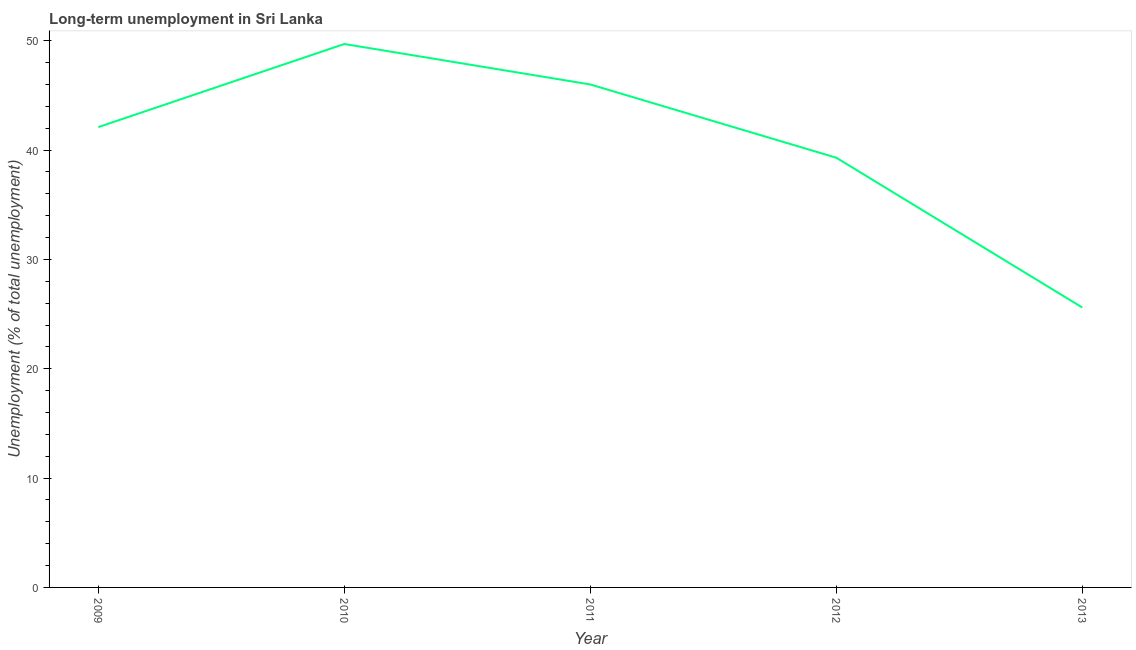What is the long-term unemployment in 2010?
Make the answer very short. 49.7. Across all years, what is the maximum long-term unemployment?
Make the answer very short. 49.7. Across all years, what is the minimum long-term unemployment?
Keep it short and to the point. 25.6. In which year was the long-term unemployment minimum?
Give a very brief answer. 2013. What is the sum of the long-term unemployment?
Ensure brevity in your answer.  202.7. What is the difference between the long-term unemployment in 2012 and 2013?
Make the answer very short. 13.7. What is the average long-term unemployment per year?
Your response must be concise. 40.54. What is the median long-term unemployment?
Your answer should be very brief. 42.1. In how many years, is the long-term unemployment greater than 44 %?
Ensure brevity in your answer.  2. What is the ratio of the long-term unemployment in 2009 to that in 2010?
Ensure brevity in your answer.  0.85. Is the difference between the long-term unemployment in 2010 and 2012 greater than the difference between any two years?
Offer a very short reply. No. What is the difference between the highest and the second highest long-term unemployment?
Provide a short and direct response. 3.7. What is the difference between the highest and the lowest long-term unemployment?
Keep it short and to the point. 24.1. Does the graph contain grids?
Offer a very short reply. No. What is the title of the graph?
Your response must be concise. Long-term unemployment in Sri Lanka. What is the label or title of the Y-axis?
Your answer should be compact. Unemployment (% of total unemployment). What is the Unemployment (% of total unemployment) of 2009?
Provide a short and direct response. 42.1. What is the Unemployment (% of total unemployment) of 2010?
Make the answer very short. 49.7. What is the Unemployment (% of total unemployment) in 2012?
Your response must be concise. 39.3. What is the Unemployment (% of total unemployment) of 2013?
Keep it short and to the point. 25.6. What is the difference between the Unemployment (% of total unemployment) in 2009 and 2010?
Ensure brevity in your answer.  -7.6. What is the difference between the Unemployment (% of total unemployment) in 2009 and 2011?
Ensure brevity in your answer.  -3.9. What is the difference between the Unemployment (% of total unemployment) in 2010 and 2011?
Give a very brief answer. 3.7. What is the difference between the Unemployment (% of total unemployment) in 2010 and 2013?
Give a very brief answer. 24.1. What is the difference between the Unemployment (% of total unemployment) in 2011 and 2012?
Offer a very short reply. 6.7. What is the difference between the Unemployment (% of total unemployment) in 2011 and 2013?
Your answer should be compact. 20.4. What is the ratio of the Unemployment (% of total unemployment) in 2009 to that in 2010?
Provide a short and direct response. 0.85. What is the ratio of the Unemployment (% of total unemployment) in 2009 to that in 2011?
Make the answer very short. 0.92. What is the ratio of the Unemployment (% of total unemployment) in 2009 to that in 2012?
Your answer should be very brief. 1.07. What is the ratio of the Unemployment (% of total unemployment) in 2009 to that in 2013?
Offer a terse response. 1.65. What is the ratio of the Unemployment (% of total unemployment) in 2010 to that in 2012?
Keep it short and to the point. 1.26. What is the ratio of the Unemployment (% of total unemployment) in 2010 to that in 2013?
Your answer should be compact. 1.94. What is the ratio of the Unemployment (% of total unemployment) in 2011 to that in 2012?
Give a very brief answer. 1.17. What is the ratio of the Unemployment (% of total unemployment) in 2011 to that in 2013?
Ensure brevity in your answer.  1.8. What is the ratio of the Unemployment (% of total unemployment) in 2012 to that in 2013?
Your response must be concise. 1.53. 